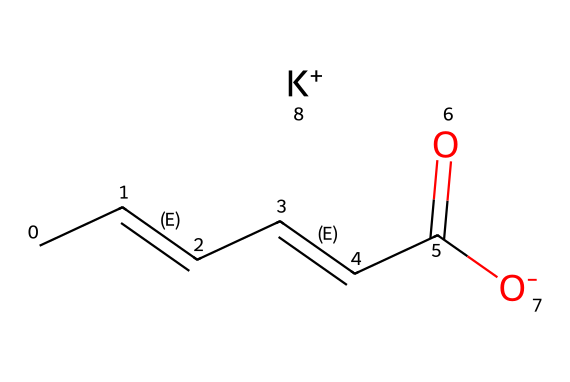what is the name of this chemical? The SMILES representation provided corresponds to potassium sorbate, a commonly used food preservative. The structure includes a potassium ion (K+) and the sorbate molecule.
Answer: potassium sorbate how many carbon atoms are present in this compound? By analyzing the SMILES, we can count the carbon atoms represented by "C". There are six "C" in the structure.
Answer: 6 what type of bond connects the carbon atoms in this compound? The structure shows multiple "C=C" double bonds between carbon atoms, which indicates that there are double bonds connecting some of the carbon atoms.
Answer: double bond how many functional groups can be identified in potassium sorbate? In the SMILES, there is one carboxylate group (-COO-) present at the end of the chain, which qualifies as one functional group.
Answer: 1 which part of the molecule indicates that it is a preservative? The carboxylate part (-COO-) is indicative of the preservative nature, as carboxylic acids and their derivatives often have antimicrobial properties.
Answer: carboxylate what is the charge of the potassium ion in this chemical? The SMILES indicates the presence of "[K+]", which denotes that the potassium ion has a positive charge.
Answer: positive 